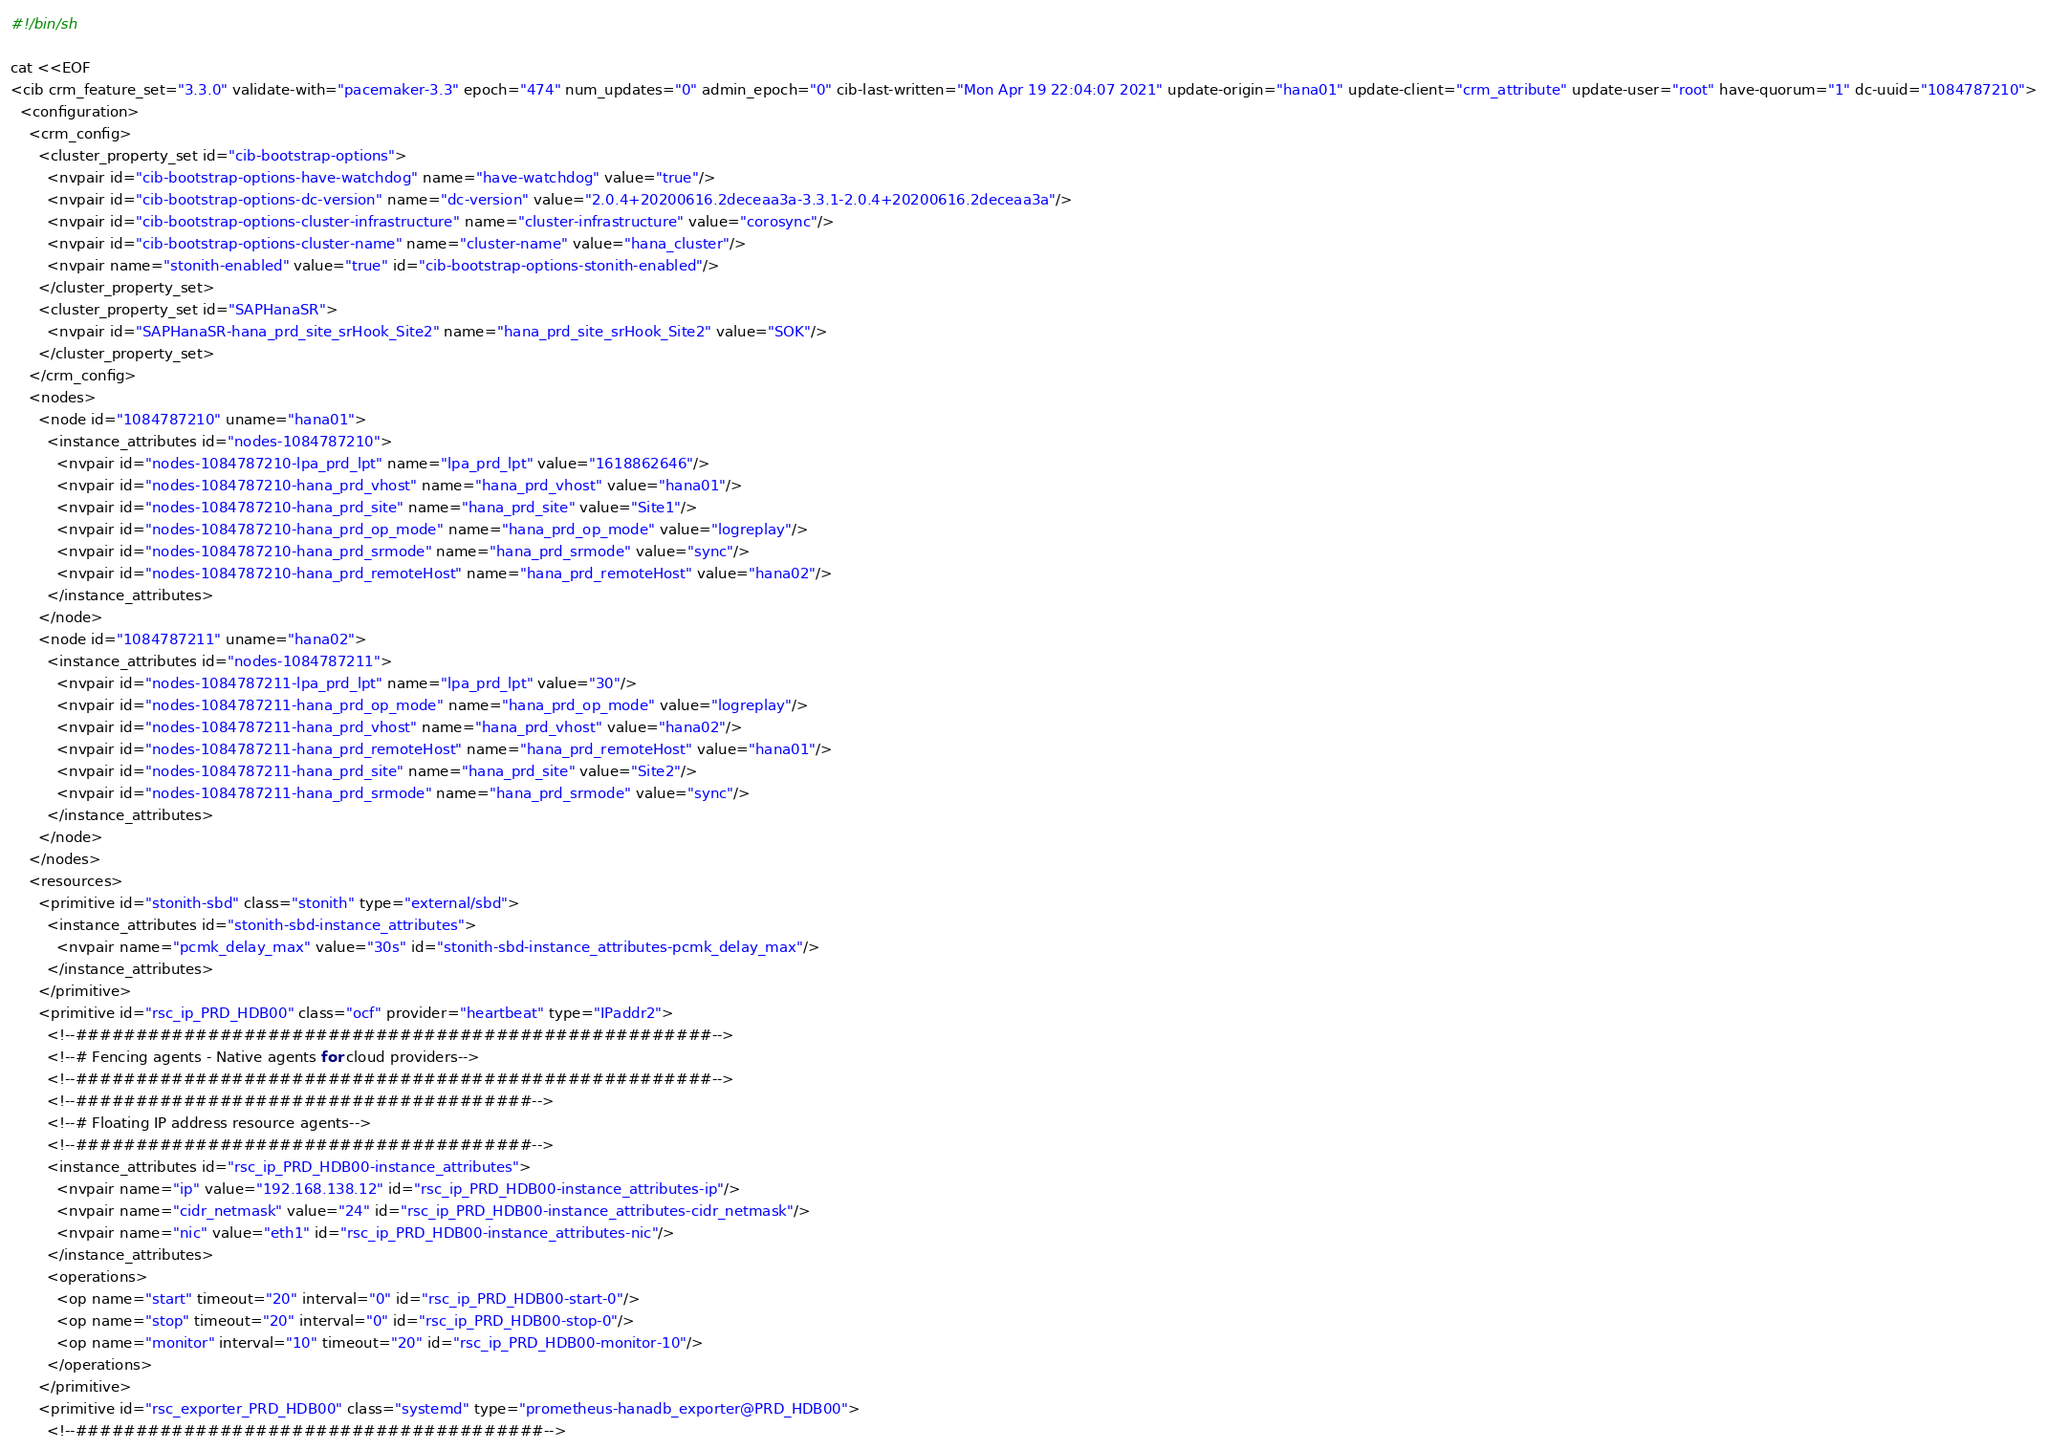<code> <loc_0><loc_0><loc_500><loc_500><_Bash_>#!/bin/sh

cat <<EOF
<cib crm_feature_set="3.3.0" validate-with="pacemaker-3.3" epoch="474" num_updates="0" admin_epoch="0" cib-last-written="Mon Apr 19 22:04:07 2021" update-origin="hana01" update-client="crm_attribute" update-user="root" have-quorum="1" dc-uuid="1084787210">
  <configuration>
    <crm_config>
      <cluster_property_set id="cib-bootstrap-options">
        <nvpair id="cib-bootstrap-options-have-watchdog" name="have-watchdog" value="true"/>
        <nvpair id="cib-bootstrap-options-dc-version" name="dc-version" value="2.0.4+20200616.2deceaa3a-3.3.1-2.0.4+20200616.2deceaa3a"/>
        <nvpair id="cib-bootstrap-options-cluster-infrastructure" name="cluster-infrastructure" value="corosync"/>
        <nvpair id="cib-bootstrap-options-cluster-name" name="cluster-name" value="hana_cluster"/>
        <nvpair name="stonith-enabled" value="true" id="cib-bootstrap-options-stonith-enabled"/>
      </cluster_property_set>
      <cluster_property_set id="SAPHanaSR">
        <nvpair id="SAPHanaSR-hana_prd_site_srHook_Site2" name="hana_prd_site_srHook_Site2" value="SOK"/>
      </cluster_property_set>
    </crm_config>
    <nodes>
      <node id="1084787210" uname="hana01">
        <instance_attributes id="nodes-1084787210">
          <nvpair id="nodes-1084787210-lpa_prd_lpt" name="lpa_prd_lpt" value="1618862646"/>
          <nvpair id="nodes-1084787210-hana_prd_vhost" name="hana_prd_vhost" value="hana01"/>
          <nvpair id="nodes-1084787210-hana_prd_site" name="hana_prd_site" value="Site1"/>
          <nvpair id="nodes-1084787210-hana_prd_op_mode" name="hana_prd_op_mode" value="logreplay"/>
          <nvpair id="nodes-1084787210-hana_prd_srmode" name="hana_prd_srmode" value="sync"/>
          <nvpair id="nodes-1084787210-hana_prd_remoteHost" name="hana_prd_remoteHost" value="hana02"/>
        </instance_attributes>
      </node>
      <node id="1084787211" uname="hana02">
        <instance_attributes id="nodes-1084787211">
          <nvpair id="nodes-1084787211-lpa_prd_lpt" name="lpa_prd_lpt" value="30"/>
          <nvpair id="nodes-1084787211-hana_prd_op_mode" name="hana_prd_op_mode" value="logreplay"/>
          <nvpair id="nodes-1084787211-hana_prd_vhost" name="hana_prd_vhost" value="hana02"/>
          <nvpair id="nodes-1084787211-hana_prd_remoteHost" name="hana_prd_remoteHost" value="hana01"/>
          <nvpair id="nodes-1084787211-hana_prd_site" name="hana_prd_site" value="Site2"/>
          <nvpair id="nodes-1084787211-hana_prd_srmode" name="hana_prd_srmode" value="sync"/>
        </instance_attributes>
      </node>
    </nodes>
    <resources>
      <primitive id="stonith-sbd" class="stonith" type="external/sbd">
        <instance_attributes id="stonith-sbd-instance_attributes">
          <nvpair name="pcmk_delay_max" value="30s" id="stonith-sbd-instance_attributes-pcmk_delay_max"/>
        </instance_attributes>
      </primitive>
      <primitive id="rsc_ip_PRD_HDB00" class="ocf" provider="heartbeat" type="IPaddr2">
        <!--#####################################################-->
        <!--# Fencing agents - Native agents for cloud providers-->
        <!--#####################################################-->
        <!--######################################-->
        <!--# Floating IP address resource agents-->
        <!--######################################-->
        <instance_attributes id="rsc_ip_PRD_HDB00-instance_attributes">
          <nvpair name="ip" value="192.168.138.12" id="rsc_ip_PRD_HDB00-instance_attributes-ip"/>
          <nvpair name="cidr_netmask" value="24" id="rsc_ip_PRD_HDB00-instance_attributes-cidr_netmask"/>
          <nvpair name="nic" value="eth1" id="rsc_ip_PRD_HDB00-instance_attributes-nic"/>
        </instance_attributes>
        <operations>
          <op name="start" timeout="20" interval="0" id="rsc_ip_PRD_HDB00-start-0"/>
          <op name="stop" timeout="20" interval="0" id="rsc_ip_PRD_HDB00-stop-0"/>
          <op name="monitor" interval="10" timeout="20" id="rsc_ip_PRD_HDB00-monitor-10"/>
        </operations>
      </primitive>
      <primitive id="rsc_exporter_PRD_HDB00" class="systemd" type="prometheus-hanadb_exporter@PRD_HDB00">
        <!--#######################################--></code> 